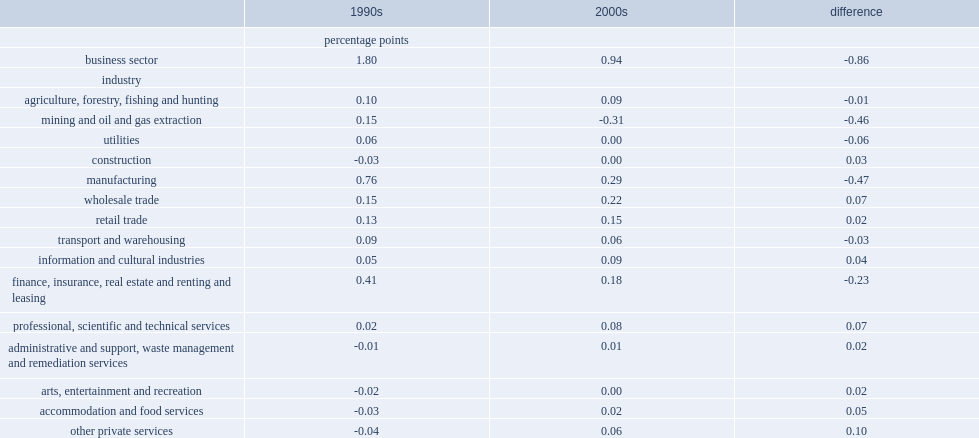In mining, manufacturing and finance industries, respectively, what percent of the contribution from direct productivity growth between the two periods has changed? 0.46 0.47 0.23. 